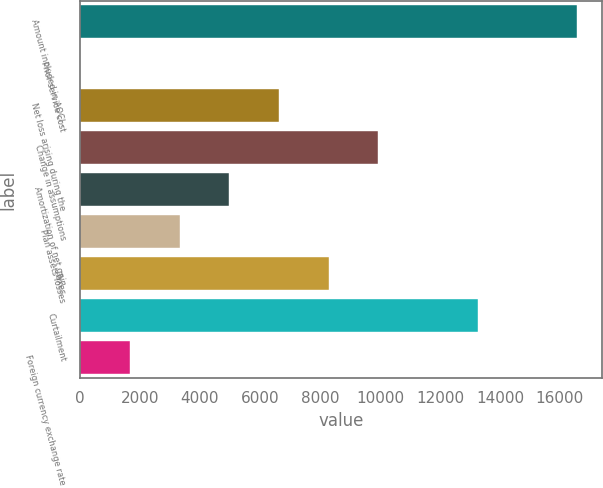Convert chart. <chart><loc_0><loc_0><loc_500><loc_500><bar_chart><fcel>Amount included in AOCI -<fcel>Prior service cost<fcel>Net loss arising during the<fcel>Change in assumptions<fcel>Amortization of net gain<fcel>Plan assets losses<fcel>Taxes<fcel>Curtailment<fcel>Foreign currency exchange rate<nl><fcel>16570<fcel>9<fcel>6633.4<fcel>9945.6<fcel>4977.3<fcel>3321.2<fcel>8289.5<fcel>13257.8<fcel>1665.1<nl></chart> 